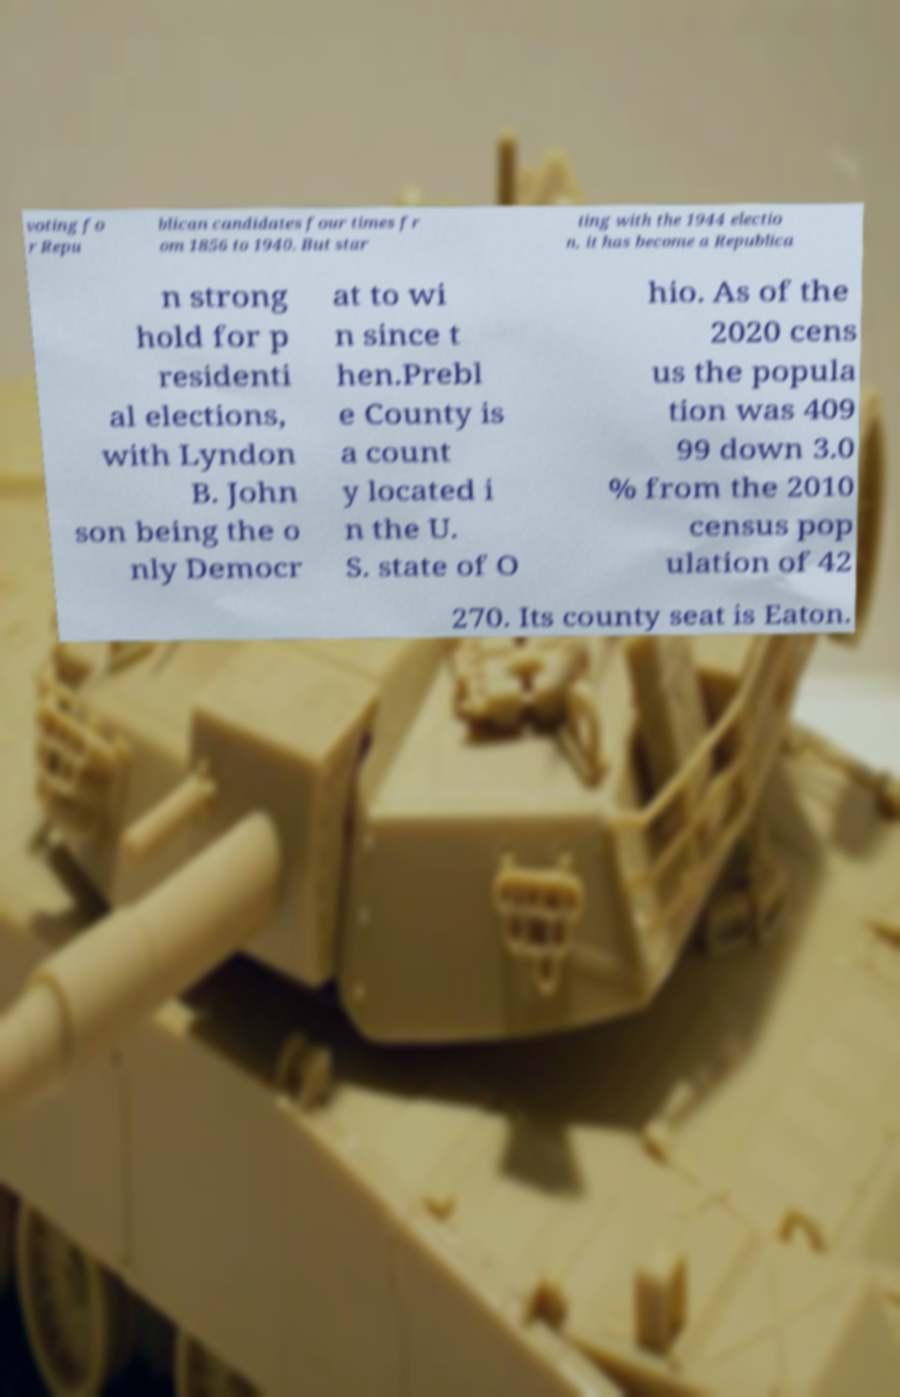Please read and relay the text visible in this image. What does it say? voting fo r Repu blican candidates four times fr om 1856 to 1940. But star ting with the 1944 electio n, it has become a Republica n strong hold for p residenti al elections, with Lyndon B. John son being the o nly Democr at to wi n since t hen.Prebl e County is a count y located i n the U. S. state of O hio. As of the 2020 cens us the popula tion was 409 99 down 3.0 % from the 2010 census pop ulation of 42 270. Its county seat is Eaton. 